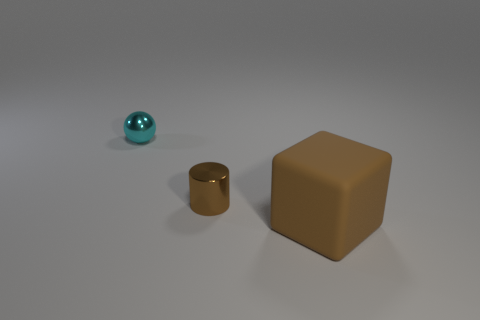Add 1 green shiny spheres. How many objects exist? 4 Subtract all balls. How many objects are left? 2 Add 2 gray metal spheres. How many gray metal spheres exist? 2 Subtract 1 brown cylinders. How many objects are left? 2 Subtract all purple cubes. Subtract all green cylinders. How many cubes are left? 1 Subtract all small brown metal cylinders. Subtract all big brown cubes. How many objects are left? 1 Add 3 balls. How many balls are left? 4 